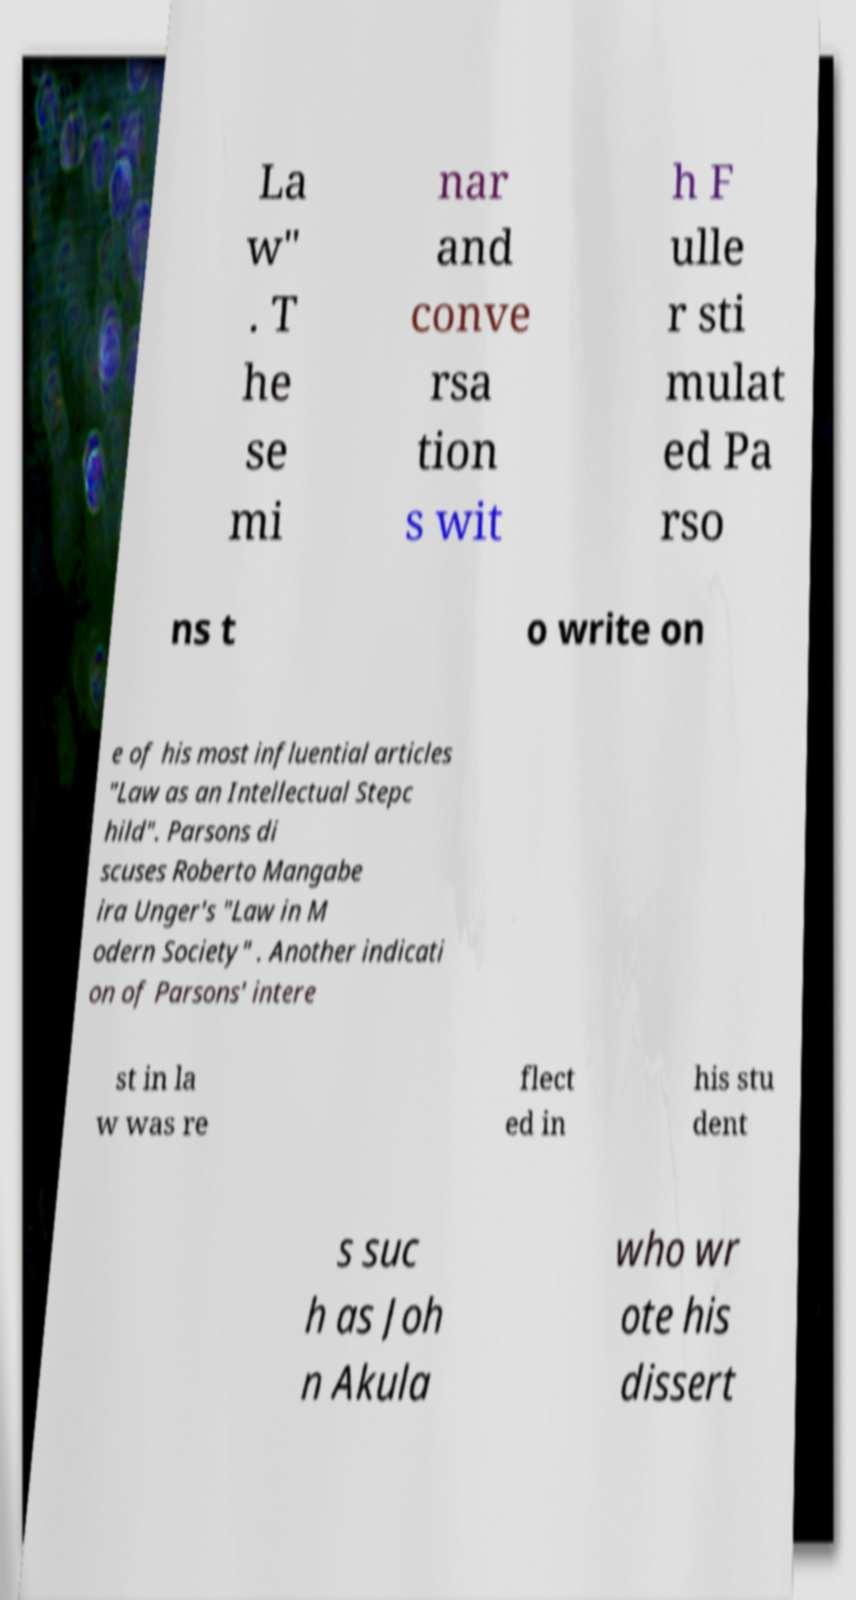Can you accurately transcribe the text from the provided image for me? La w" . T he se mi nar and conve rsa tion s wit h F ulle r sti mulat ed Pa rso ns t o write on e of his most influential articles "Law as an Intellectual Stepc hild". Parsons di scuses Roberto Mangabe ira Unger's "Law in M odern Society" . Another indicati on of Parsons' intere st in la w was re flect ed in his stu dent s suc h as Joh n Akula who wr ote his dissert 